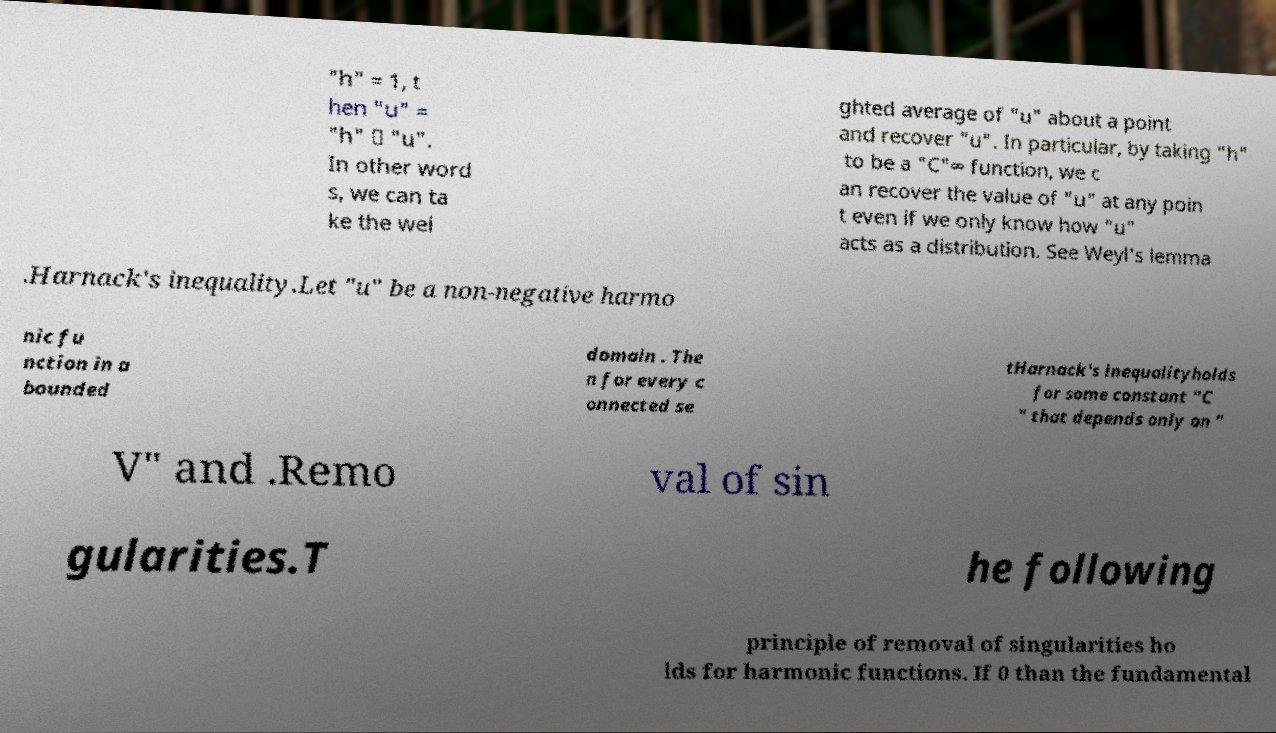For documentation purposes, I need the text within this image transcribed. Could you provide that? "h" = 1, t hen "u" = "h" ∗ "u". In other word s, we can ta ke the wei ghted average of "u" about a point and recover "u". In particular, by taking "h" to be a "C"∞ function, we c an recover the value of "u" at any poin t even if we only know how "u" acts as a distribution. See Weyl's lemma .Harnack's inequality.Let "u" be a non-negative harmo nic fu nction in a bounded domain . The n for every c onnected se tHarnack's inequalityholds for some constant "C " that depends only on " V" and .Remo val of sin gularities.T he following principle of removal of singularities ho lds for harmonic functions. If 0 than the fundamental 